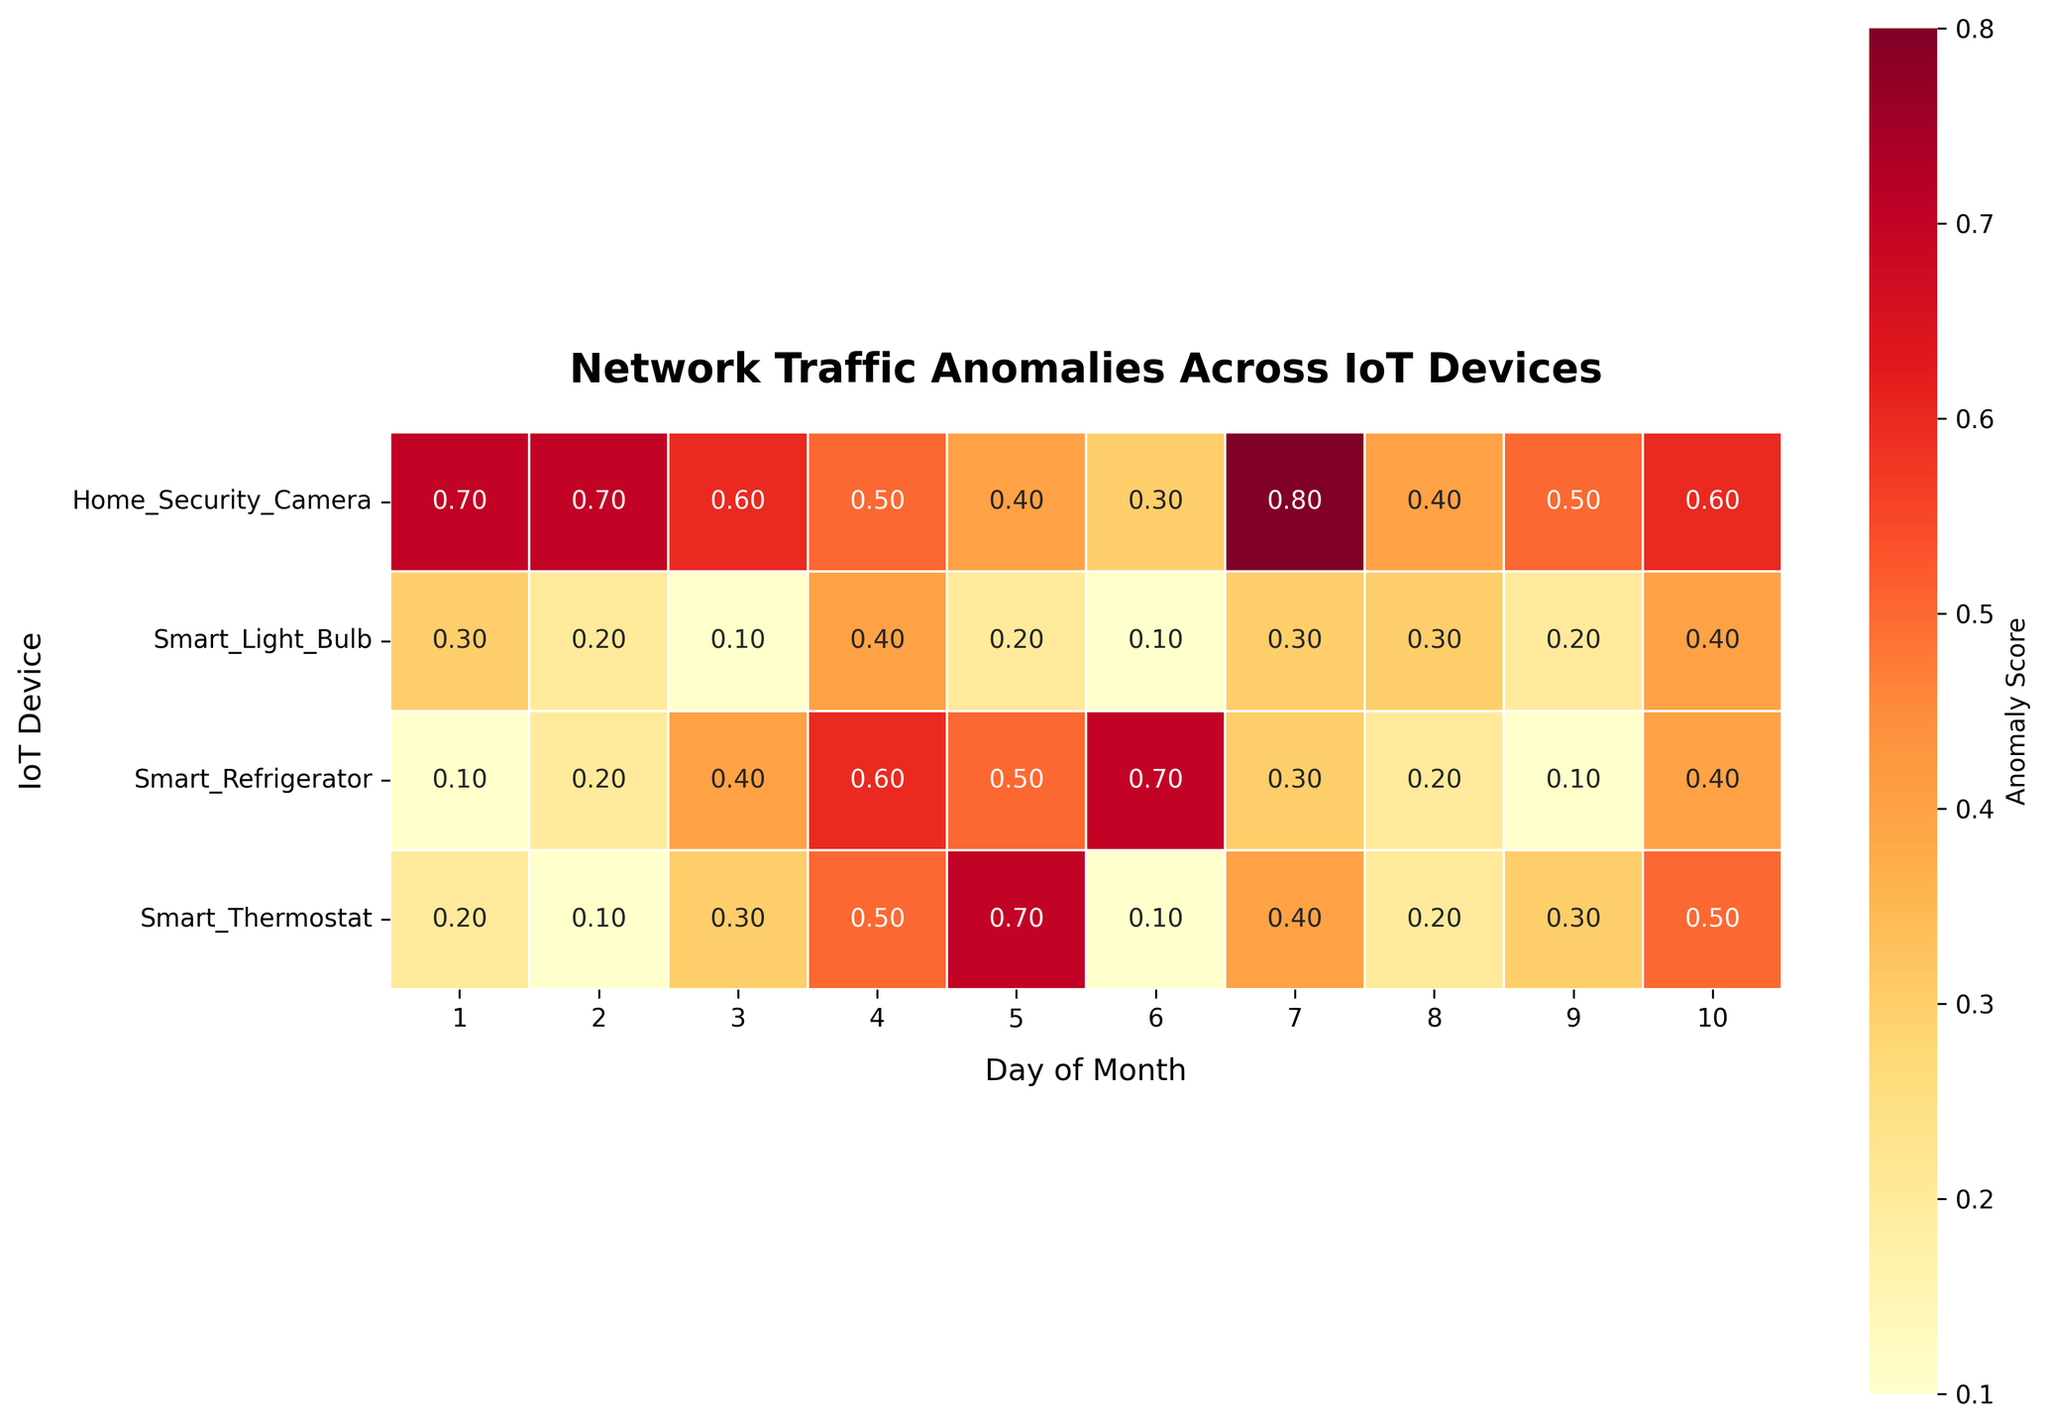What is the title of the heatmap? The title is usually located at the top of the figure and is labeled with a larger, bold font. Look at the top-center of the heatmap.
Answer: Network Traffic Anomalies Across IoT Devices On which day did the Smart Thermostat have the highest anomaly score? Find "Smart Thermostat" on the left vertical axis, then look across the row to identify the highest numerical value.
Answer: Day 5 Which IoT device had the highest anomaly score on the first day of the month? Look at the first column, which represents the first day of the month, and find the largest number across all the rows (IoT devices).
Answer: Home Security Camera What is the average anomaly score for the Smart Refrigerator over the 10 days? Sum the anomaly scores for "Smart Refrigerator" for all 10 days and then divide by 10.
Answer: 0.35 How does the anomaly score of the Home Security Camera on day 7 compare to the Smart Thermostat on the same day? Locate "Home Security Camera" and "Smart Thermostat" in the 7th column (day 7) and compare the two values.
Answer: Home Security Camera is higher Which IoT device has the most consistent anomaly scores across the 10 days, based on visual uniformity in the heatmap? Look for the row where the colors (heatmap intensity) are the most similar across the entire row.
Answer: Smart Light Bulb What is the difference in the anomaly score between the Smart Refrigerator and Smart Light Bulb on day 4? Find the values for "Smart Refrigerator" and "Smart Light Bulb" on day 4 and subtract the smaller from the larger.
Answer: 0.2 On which day did the Smart Thermostat and Home Security Camera both have the same anomaly score? Compare the anomaly scores of "Smart Thermostat" and "Home Security Camera" across all days and identify the day where they match.
Answer: Day 4 Which device had the lowest anomaly score on day 9? Locate the 9th column and determine which row has the smallest numerical value.
Answer: Smart Refrigerator 